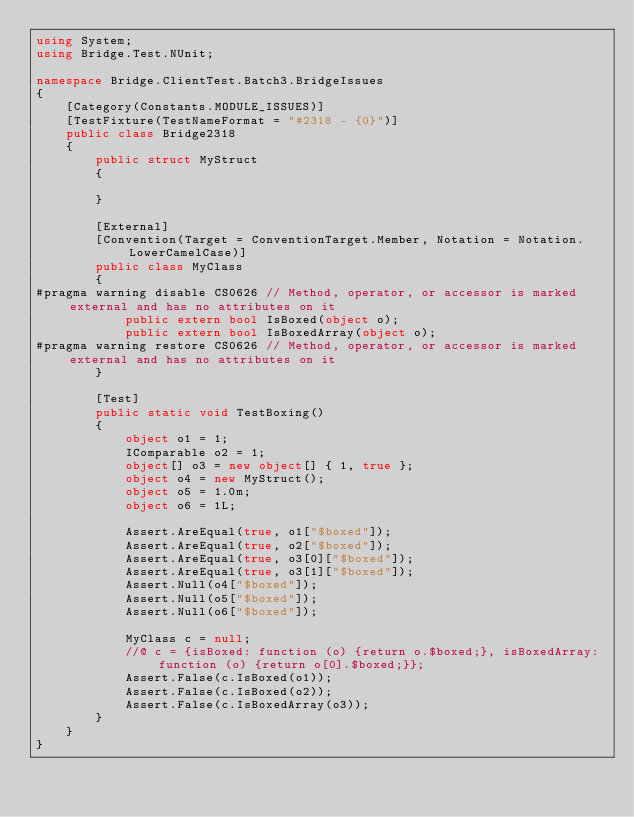Convert code to text. <code><loc_0><loc_0><loc_500><loc_500><_C#_>using System;
using Bridge.Test.NUnit;

namespace Bridge.ClientTest.Batch3.BridgeIssues
{
    [Category(Constants.MODULE_ISSUES)]
    [TestFixture(TestNameFormat = "#2318 - {0}")]
    public class Bridge2318
    {
        public struct MyStruct
        {
            
        }

        [External]
        [Convention(Target = ConventionTarget.Member, Notation = Notation.LowerCamelCase)]
        public class MyClass
        {
#pragma warning disable CS0626 // Method, operator, or accessor is marked external and has no attributes on it
            public extern bool IsBoxed(object o);
            public extern bool IsBoxedArray(object o);
#pragma warning restore CS0626 // Method, operator, or accessor is marked external and has no attributes on it
        }

        [Test]
        public static void TestBoxing()
        {
            object o1 = 1;
            IComparable o2 = 1;
            object[] o3 = new object[] { 1, true };
            object o4 = new MyStruct();
            object o5 = 1.0m;
            object o6 = 1L;

            Assert.AreEqual(true, o1["$boxed"]);
            Assert.AreEqual(true, o2["$boxed"]);
            Assert.AreEqual(true, o3[0]["$boxed"]);
            Assert.AreEqual(true, o3[1]["$boxed"]);
            Assert.Null(o4["$boxed"]);
            Assert.Null(o5["$boxed"]);
            Assert.Null(o6["$boxed"]);

            MyClass c = null;
            //@ c = {isBoxed: function (o) {return o.$boxed;}, isBoxedArray: function (o) {return o[0].$boxed;}};
            Assert.False(c.IsBoxed(o1));
            Assert.False(c.IsBoxed(o2));
            Assert.False(c.IsBoxedArray(o3));
        }
    }
}</code> 